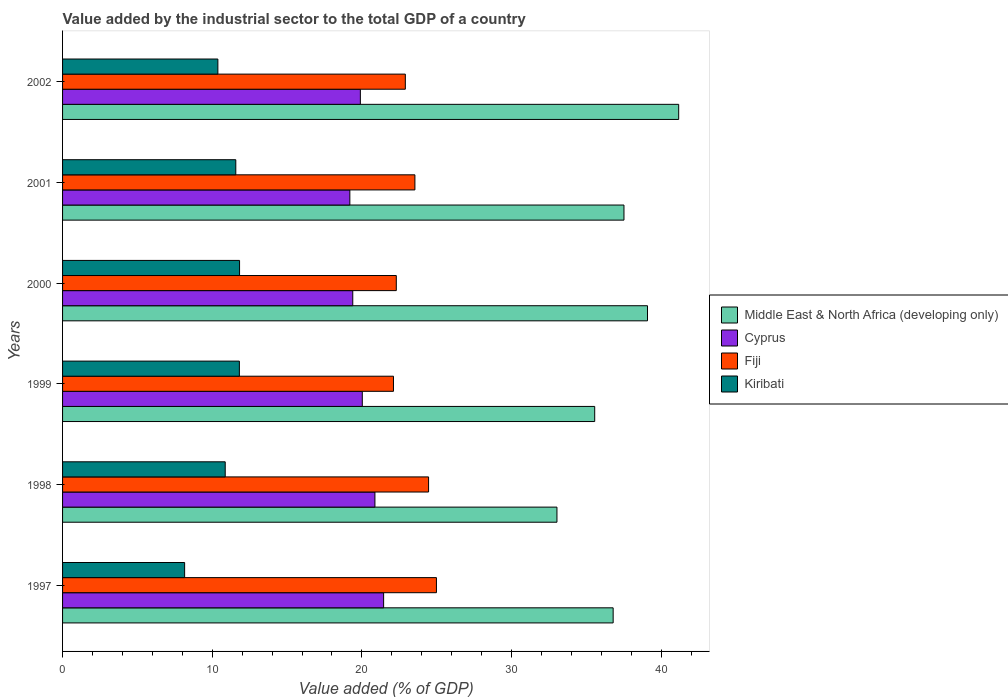How many groups of bars are there?
Give a very brief answer. 6. Are the number of bars on each tick of the Y-axis equal?
Keep it short and to the point. Yes. How many bars are there on the 2nd tick from the top?
Keep it short and to the point. 4. What is the value added by the industrial sector to the total GDP in Kiribati in 1999?
Provide a succinct answer. 11.81. Across all years, what is the maximum value added by the industrial sector to the total GDP in Middle East & North Africa (developing only)?
Keep it short and to the point. 41.16. Across all years, what is the minimum value added by the industrial sector to the total GDP in Kiribati?
Provide a short and direct response. 8.16. In which year was the value added by the industrial sector to the total GDP in Kiribati maximum?
Keep it short and to the point. 2000. What is the total value added by the industrial sector to the total GDP in Cyprus in the graph?
Keep it short and to the point. 120.82. What is the difference between the value added by the industrial sector to the total GDP in Cyprus in 1997 and that in 2001?
Give a very brief answer. 2.26. What is the difference between the value added by the industrial sector to the total GDP in Cyprus in 1998 and the value added by the industrial sector to the total GDP in Fiji in 2001?
Your answer should be very brief. -2.67. What is the average value added by the industrial sector to the total GDP in Cyprus per year?
Offer a very short reply. 20.14. In the year 1997, what is the difference between the value added by the industrial sector to the total GDP in Middle East & North Africa (developing only) and value added by the industrial sector to the total GDP in Fiji?
Provide a short and direct response. 11.81. What is the ratio of the value added by the industrial sector to the total GDP in Kiribati in 1997 to that in 2001?
Provide a short and direct response. 0.7. Is the difference between the value added by the industrial sector to the total GDP in Middle East & North Africa (developing only) in 2001 and 2002 greater than the difference between the value added by the industrial sector to the total GDP in Fiji in 2001 and 2002?
Your answer should be compact. No. What is the difference between the highest and the second highest value added by the industrial sector to the total GDP in Cyprus?
Your answer should be very brief. 0.58. What is the difference between the highest and the lowest value added by the industrial sector to the total GDP in Middle East & North Africa (developing only)?
Provide a succinct answer. 8.13. Is the sum of the value added by the industrial sector to the total GDP in Fiji in 1999 and 2002 greater than the maximum value added by the industrial sector to the total GDP in Middle East & North Africa (developing only) across all years?
Make the answer very short. Yes. What does the 4th bar from the top in 1998 represents?
Keep it short and to the point. Middle East & North Africa (developing only). What does the 1st bar from the bottom in 2000 represents?
Your answer should be very brief. Middle East & North Africa (developing only). How many bars are there?
Offer a terse response. 24. Are all the bars in the graph horizontal?
Make the answer very short. Yes. How many years are there in the graph?
Give a very brief answer. 6. Are the values on the major ticks of X-axis written in scientific E-notation?
Keep it short and to the point. No. Does the graph contain any zero values?
Your answer should be compact. No. What is the title of the graph?
Offer a terse response. Value added by the industrial sector to the total GDP of a country. What is the label or title of the X-axis?
Keep it short and to the point. Value added (% of GDP). What is the label or title of the Y-axis?
Your answer should be compact. Years. What is the Value added (% of GDP) of Middle East & North Africa (developing only) in 1997?
Keep it short and to the point. 36.79. What is the Value added (% of GDP) of Cyprus in 1997?
Offer a very short reply. 21.45. What is the Value added (% of GDP) in Fiji in 1997?
Offer a very short reply. 24.98. What is the Value added (% of GDP) of Kiribati in 1997?
Keep it short and to the point. 8.16. What is the Value added (% of GDP) in Middle East & North Africa (developing only) in 1998?
Offer a terse response. 33.03. What is the Value added (% of GDP) in Cyprus in 1998?
Keep it short and to the point. 20.87. What is the Value added (% of GDP) in Fiji in 1998?
Make the answer very short. 24.45. What is the Value added (% of GDP) of Kiribati in 1998?
Your answer should be compact. 10.87. What is the Value added (% of GDP) of Middle East & North Africa (developing only) in 1999?
Ensure brevity in your answer.  35.55. What is the Value added (% of GDP) of Cyprus in 1999?
Keep it short and to the point. 20.02. What is the Value added (% of GDP) in Fiji in 1999?
Provide a succinct answer. 22.11. What is the Value added (% of GDP) in Kiribati in 1999?
Provide a short and direct response. 11.81. What is the Value added (% of GDP) of Middle East & North Africa (developing only) in 2000?
Ensure brevity in your answer.  39.08. What is the Value added (% of GDP) in Cyprus in 2000?
Offer a terse response. 19.39. What is the Value added (% of GDP) of Fiji in 2000?
Make the answer very short. 22.3. What is the Value added (% of GDP) in Kiribati in 2000?
Keep it short and to the point. 11.82. What is the Value added (% of GDP) in Middle East & North Africa (developing only) in 2001?
Provide a succinct answer. 37.51. What is the Value added (% of GDP) in Cyprus in 2001?
Ensure brevity in your answer.  19.19. What is the Value added (% of GDP) in Fiji in 2001?
Offer a terse response. 23.54. What is the Value added (% of GDP) of Kiribati in 2001?
Ensure brevity in your answer.  11.57. What is the Value added (% of GDP) in Middle East & North Africa (developing only) in 2002?
Make the answer very short. 41.16. What is the Value added (% of GDP) in Cyprus in 2002?
Offer a very short reply. 19.9. What is the Value added (% of GDP) of Fiji in 2002?
Make the answer very short. 22.9. What is the Value added (% of GDP) in Kiribati in 2002?
Your response must be concise. 10.38. Across all years, what is the maximum Value added (% of GDP) of Middle East & North Africa (developing only)?
Give a very brief answer. 41.16. Across all years, what is the maximum Value added (% of GDP) in Cyprus?
Give a very brief answer. 21.45. Across all years, what is the maximum Value added (% of GDP) in Fiji?
Offer a terse response. 24.98. Across all years, what is the maximum Value added (% of GDP) in Kiribati?
Give a very brief answer. 11.82. Across all years, what is the minimum Value added (% of GDP) in Middle East & North Africa (developing only)?
Make the answer very short. 33.03. Across all years, what is the minimum Value added (% of GDP) of Cyprus?
Keep it short and to the point. 19.19. Across all years, what is the minimum Value added (% of GDP) of Fiji?
Your answer should be very brief. 22.11. Across all years, what is the minimum Value added (% of GDP) in Kiribati?
Your response must be concise. 8.16. What is the total Value added (% of GDP) in Middle East & North Africa (developing only) in the graph?
Keep it short and to the point. 223.12. What is the total Value added (% of GDP) of Cyprus in the graph?
Provide a short and direct response. 120.82. What is the total Value added (% of GDP) in Fiji in the graph?
Offer a very short reply. 140.28. What is the total Value added (% of GDP) in Kiribati in the graph?
Provide a succinct answer. 64.61. What is the difference between the Value added (% of GDP) in Middle East & North Africa (developing only) in 1997 and that in 1998?
Your answer should be very brief. 3.75. What is the difference between the Value added (% of GDP) in Cyprus in 1997 and that in 1998?
Provide a succinct answer. 0.58. What is the difference between the Value added (% of GDP) in Fiji in 1997 and that in 1998?
Your answer should be compact. 0.52. What is the difference between the Value added (% of GDP) of Kiribati in 1997 and that in 1998?
Ensure brevity in your answer.  -2.71. What is the difference between the Value added (% of GDP) of Middle East & North Africa (developing only) in 1997 and that in 1999?
Your answer should be very brief. 1.23. What is the difference between the Value added (% of GDP) of Cyprus in 1997 and that in 1999?
Your response must be concise. 1.43. What is the difference between the Value added (% of GDP) in Fiji in 1997 and that in 1999?
Offer a terse response. 2.87. What is the difference between the Value added (% of GDP) of Kiribati in 1997 and that in 1999?
Offer a terse response. -3.66. What is the difference between the Value added (% of GDP) of Middle East & North Africa (developing only) in 1997 and that in 2000?
Your answer should be compact. -2.29. What is the difference between the Value added (% of GDP) of Cyprus in 1997 and that in 2000?
Provide a succinct answer. 2.06. What is the difference between the Value added (% of GDP) in Fiji in 1997 and that in 2000?
Provide a short and direct response. 2.68. What is the difference between the Value added (% of GDP) of Kiribati in 1997 and that in 2000?
Your response must be concise. -3.67. What is the difference between the Value added (% of GDP) in Middle East & North Africa (developing only) in 1997 and that in 2001?
Provide a succinct answer. -0.72. What is the difference between the Value added (% of GDP) in Cyprus in 1997 and that in 2001?
Your answer should be very brief. 2.26. What is the difference between the Value added (% of GDP) in Fiji in 1997 and that in 2001?
Provide a short and direct response. 1.44. What is the difference between the Value added (% of GDP) in Kiribati in 1997 and that in 2001?
Keep it short and to the point. -3.42. What is the difference between the Value added (% of GDP) in Middle East & North Africa (developing only) in 1997 and that in 2002?
Provide a succinct answer. -4.38. What is the difference between the Value added (% of GDP) of Cyprus in 1997 and that in 2002?
Your answer should be very brief. 1.55. What is the difference between the Value added (% of GDP) in Fiji in 1997 and that in 2002?
Provide a short and direct response. 2.08. What is the difference between the Value added (% of GDP) in Kiribati in 1997 and that in 2002?
Offer a very short reply. -2.22. What is the difference between the Value added (% of GDP) of Middle East & North Africa (developing only) in 1998 and that in 1999?
Provide a short and direct response. -2.52. What is the difference between the Value added (% of GDP) in Cyprus in 1998 and that in 1999?
Offer a terse response. 0.84. What is the difference between the Value added (% of GDP) of Fiji in 1998 and that in 1999?
Offer a terse response. 2.35. What is the difference between the Value added (% of GDP) of Kiribati in 1998 and that in 1999?
Give a very brief answer. -0.95. What is the difference between the Value added (% of GDP) of Middle East & North Africa (developing only) in 1998 and that in 2000?
Provide a succinct answer. -6.05. What is the difference between the Value added (% of GDP) in Cyprus in 1998 and that in 2000?
Ensure brevity in your answer.  1.48. What is the difference between the Value added (% of GDP) in Fiji in 1998 and that in 2000?
Your answer should be very brief. 2.16. What is the difference between the Value added (% of GDP) in Kiribati in 1998 and that in 2000?
Ensure brevity in your answer.  -0.96. What is the difference between the Value added (% of GDP) in Middle East & North Africa (developing only) in 1998 and that in 2001?
Provide a succinct answer. -4.48. What is the difference between the Value added (% of GDP) in Cyprus in 1998 and that in 2001?
Your answer should be very brief. 1.68. What is the difference between the Value added (% of GDP) in Fiji in 1998 and that in 2001?
Give a very brief answer. 0.91. What is the difference between the Value added (% of GDP) in Kiribati in 1998 and that in 2001?
Provide a succinct answer. -0.71. What is the difference between the Value added (% of GDP) of Middle East & North Africa (developing only) in 1998 and that in 2002?
Provide a short and direct response. -8.13. What is the difference between the Value added (% of GDP) in Cyprus in 1998 and that in 2002?
Provide a succinct answer. 0.97. What is the difference between the Value added (% of GDP) of Fiji in 1998 and that in 2002?
Give a very brief answer. 1.55. What is the difference between the Value added (% of GDP) in Kiribati in 1998 and that in 2002?
Keep it short and to the point. 0.49. What is the difference between the Value added (% of GDP) in Middle East & North Africa (developing only) in 1999 and that in 2000?
Make the answer very short. -3.53. What is the difference between the Value added (% of GDP) in Cyprus in 1999 and that in 2000?
Provide a succinct answer. 0.64. What is the difference between the Value added (% of GDP) of Fiji in 1999 and that in 2000?
Make the answer very short. -0.19. What is the difference between the Value added (% of GDP) of Kiribati in 1999 and that in 2000?
Give a very brief answer. -0.01. What is the difference between the Value added (% of GDP) of Middle East & North Africa (developing only) in 1999 and that in 2001?
Make the answer very short. -1.96. What is the difference between the Value added (% of GDP) of Cyprus in 1999 and that in 2001?
Provide a short and direct response. 0.83. What is the difference between the Value added (% of GDP) in Fiji in 1999 and that in 2001?
Ensure brevity in your answer.  -1.43. What is the difference between the Value added (% of GDP) of Kiribati in 1999 and that in 2001?
Your answer should be very brief. 0.24. What is the difference between the Value added (% of GDP) of Middle East & North Africa (developing only) in 1999 and that in 2002?
Give a very brief answer. -5.61. What is the difference between the Value added (% of GDP) in Cyprus in 1999 and that in 2002?
Offer a terse response. 0.13. What is the difference between the Value added (% of GDP) in Fiji in 1999 and that in 2002?
Provide a short and direct response. -0.79. What is the difference between the Value added (% of GDP) in Kiribati in 1999 and that in 2002?
Make the answer very short. 1.44. What is the difference between the Value added (% of GDP) of Middle East & North Africa (developing only) in 2000 and that in 2001?
Provide a short and direct response. 1.57. What is the difference between the Value added (% of GDP) of Cyprus in 2000 and that in 2001?
Your answer should be very brief. 0.2. What is the difference between the Value added (% of GDP) of Fiji in 2000 and that in 2001?
Keep it short and to the point. -1.24. What is the difference between the Value added (% of GDP) of Kiribati in 2000 and that in 2001?
Offer a very short reply. 0.25. What is the difference between the Value added (% of GDP) of Middle East & North Africa (developing only) in 2000 and that in 2002?
Give a very brief answer. -2.08. What is the difference between the Value added (% of GDP) in Cyprus in 2000 and that in 2002?
Provide a short and direct response. -0.51. What is the difference between the Value added (% of GDP) in Fiji in 2000 and that in 2002?
Provide a short and direct response. -0.6. What is the difference between the Value added (% of GDP) of Kiribati in 2000 and that in 2002?
Your response must be concise. 1.45. What is the difference between the Value added (% of GDP) of Middle East & North Africa (developing only) in 2001 and that in 2002?
Give a very brief answer. -3.66. What is the difference between the Value added (% of GDP) in Cyprus in 2001 and that in 2002?
Offer a terse response. -0.7. What is the difference between the Value added (% of GDP) of Fiji in 2001 and that in 2002?
Give a very brief answer. 0.64. What is the difference between the Value added (% of GDP) of Kiribati in 2001 and that in 2002?
Keep it short and to the point. 1.2. What is the difference between the Value added (% of GDP) of Middle East & North Africa (developing only) in 1997 and the Value added (% of GDP) of Cyprus in 1998?
Provide a succinct answer. 15.92. What is the difference between the Value added (% of GDP) in Middle East & North Africa (developing only) in 1997 and the Value added (% of GDP) in Fiji in 1998?
Keep it short and to the point. 12.33. What is the difference between the Value added (% of GDP) of Middle East & North Africa (developing only) in 1997 and the Value added (% of GDP) of Kiribati in 1998?
Offer a terse response. 25.92. What is the difference between the Value added (% of GDP) of Cyprus in 1997 and the Value added (% of GDP) of Fiji in 1998?
Offer a terse response. -3. What is the difference between the Value added (% of GDP) in Cyprus in 1997 and the Value added (% of GDP) in Kiribati in 1998?
Your response must be concise. 10.58. What is the difference between the Value added (% of GDP) in Fiji in 1997 and the Value added (% of GDP) in Kiribati in 1998?
Offer a terse response. 14.11. What is the difference between the Value added (% of GDP) of Middle East & North Africa (developing only) in 1997 and the Value added (% of GDP) of Cyprus in 1999?
Provide a succinct answer. 16.76. What is the difference between the Value added (% of GDP) in Middle East & North Africa (developing only) in 1997 and the Value added (% of GDP) in Fiji in 1999?
Make the answer very short. 14.68. What is the difference between the Value added (% of GDP) of Middle East & North Africa (developing only) in 1997 and the Value added (% of GDP) of Kiribati in 1999?
Your answer should be compact. 24.97. What is the difference between the Value added (% of GDP) in Cyprus in 1997 and the Value added (% of GDP) in Fiji in 1999?
Provide a succinct answer. -0.66. What is the difference between the Value added (% of GDP) in Cyprus in 1997 and the Value added (% of GDP) in Kiribati in 1999?
Provide a short and direct response. 9.64. What is the difference between the Value added (% of GDP) of Fiji in 1997 and the Value added (% of GDP) of Kiribati in 1999?
Provide a short and direct response. 13.17. What is the difference between the Value added (% of GDP) of Middle East & North Africa (developing only) in 1997 and the Value added (% of GDP) of Cyprus in 2000?
Your answer should be compact. 17.4. What is the difference between the Value added (% of GDP) in Middle East & North Africa (developing only) in 1997 and the Value added (% of GDP) in Fiji in 2000?
Your answer should be compact. 14.49. What is the difference between the Value added (% of GDP) in Middle East & North Africa (developing only) in 1997 and the Value added (% of GDP) in Kiribati in 2000?
Make the answer very short. 24.96. What is the difference between the Value added (% of GDP) in Cyprus in 1997 and the Value added (% of GDP) in Fiji in 2000?
Keep it short and to the point. -0.85. What is the difference between the Value added (% of GDP) of Cyprus in 1997 and the Value added (% of GDP) of Kiribati in 2000?
Make the answer very short. 9.63. What is the difference between the Value added (% of GDP) in Fiji in 1997 and the Value added (% of GDP) in Kiribati in 2000?
Make the answer very short. 13.15. What is the difference between the Value added (% of GDP) of Middle East & North Africa (developing only) in 1997 and the Value added (% of GDP) of Cyprus in 2001?
Keep it short and to the point. 17.59. What is the difference between the Value added (% of GDP) in Middle East & North Africa (developing only) in 1997 and the Value added (% of GDP) in Fiji in 2001?
Provide a succinct answer. 13.24. What is the difference between the Value added (% of GDP) in Middle East & North Africa (developing only) in 1997 and the Value added (% of GDP) in Kiribati in 2001?
Your answer should be very brief. 25.21. What is the difference between the Value added (% of GDP) in Cyprus in 1997 and the Value added (% of GDP) in Fiji in 2001?
Ensure brevity in your answer.  -2.09. What is the difference between the Value added (% of GDP) in Cyprus in 1997 and the Value added (% of GDP) in Kiribati in 2001?
Keep it short and to the point. 9.88. What is the difference between the Value added (% of GDP) in Fiji in 1997 and the Value added (% of GDP) in Kiribati in 2001?
Your answer should be very brief. 13.4. What is the difference between the Value added (% of GDP) in Middle East & North Africa (developing only) in 1997 and the Value added (% of GDP) in Cyprus in 2002?
Provide a short and direct response. 16.89. What is the difference between the Value added (% of GDP) of Middle East & North Africa (developing only) in 1997 and the Value added (% of GDP) of Fiji in 2002?
Keep it short and to the point. 13.88. What is the difference between the Value added (% of GDP) in Middle East & North Africa (developing only) in 1997 and the Value added (% of GDP) in Kiribati in 2002?
Your answer should be very brief. 26.41. What is the difference between the Value added (% of GDP) in Cyprus in 1997 and the Value added (% of GDP) in Fiji in 2002?
Offer a very short reply. -1.45. What is the difference between the Value added (% of GDP) in Cyprus in 1997 and the Value added (% of GDP) in Kiribati in 2002?
Provide a succinct answer. 11.07. What is the difference between the Value added (% of GDP) in Fiji in 1997 and the Value added (% of GDP) in Kiribati in 2002?
Provide a short and direct response. 14.6. What is the difference between the Value added (% of GDP) of Middle East & North Africa (developing only) in 1998 and the Value added (% of GDP) of Cyprus in 1999?
Your answer should be compact. 13.01. What is the difference between the Value added (% of GDP) in Middle East & North Africa (developing only) in 1998 and the Value added (% of GDP) in Fiji in 1999?
Keep it short and to the point. 10.92. What is the difference between the Value added (% of GDP) in Middle East & North Africa (developing only) in 1998 and the Value added (% of GDP) in Kiribati in 1999?
Provide a short and direct response. 21.22. What is the difference between the Value added (% of GDP) in Cyprus in 1998 and the Value added (% of GDP) in Fiji in 1999?
Give a very brief answer. -1.24. What is the difference between the Value added (% of GDP) in Cyprus in 1998 and the Value added (% of GDP) in Kiribati in 1999?
Make the answer very short. 9.06. What is the difference between the Value added (% of GDP) in Fiji in 1998 and the Value added (% of GDP) in Kiribati in 1999?
Offer a very short reply. 12.64. What is the difference between the Value added (% of GDP) in Middle East & North Africa (developing only) in 1998 and the Value added (% of GDP) in Cyprus in 2000?
Make the answer very short. 13.64. What is the difference between the Value added (% of GDP) of Middle East & North Africa (developing only) in 1998 and the Value added (% of GDP) of Fiji in 2000?
Give a very brief answer. 10.73. What is the difference between the Value added (% of GDP) in Middle East & North Africa (developing only) in 1998 and the Value added (% of GDP) in Kiribati in 2000?
Keep it short and to the point. 21.21. What is the difference between the Value added (% of GDP) of Cyprus in 1998 and the Value added (% of GDP) of Fiji in 2000?
Give a very brief answer. -1.43. What is the difference between the Value added (% of GDP) of Cyprus in 1998 and the Value added (% of GDP) of Kiribati in 2000?
Your answer should be compact. 9.04. What is the difference between the Value added (% of GDP) of Fiji in 1998 and the Value added (% of GDP) of Kiribati in 2000?
Your response must be concise. 12.63. What is the difference between the Value added (% of GDP) of Middle East & North Africa (developing only) in 1998 and the Value added (% of GDP) of Cyprus in 2001?
Ensure brevity in your answer.  13.84. What is the difference between the Value added (% of GDP) of Middle East & North Africa (developing only) in 1998 and the Value added (% of GDP) of Fiji in 2001?
Offer a terse response. 9.49. What is the difference between the Value added (% of GDP) of Middle East & North Africa (developing only) in 1998 and the Value added (% of GDP) of Kiribati in 2001?
Provide a short and direct response. 21.46. What is the difference between the Value added (% of GDP) in Cyprus in 1998 and the Value added (% of GDP) in Fiji in 2001?
Provide a succinct answer. -2.67. What is the difference between the Value added (% of GDP) of Cyprus in 1998 and the Value added (% of GDP) of Kiribati in 2001?
Make the answer very short. 9.3. What is the difference between the Value added (% of GDP) of Fiji in 1998 and the Value added (% of GDP) of Kiribati in 2001?
Provide a succinct answer. 12.88. What is the difference between the Value added (% of GDP) in Middle East & North Africa (developing only) in 1998 and the Value added (% of GDP) in Cyprus in 2002?
Your answer should be very brief. 13.14. What is the difference between the Value added (% of GDP) of Middle East & North Africa (developing only) in 1998 and the Value added (% of GDP) of Fiji in 2002?
Offer a terse response. 10.13. What is the difference between the Value added (% of GDP) in Middle East & North Africa (developing only) in 1998 and the Value added (% of GDP) in Kiribati in 2002?
Offer a terse response. 22.65. What is the difference between the Value added (% of GDP) of Cyprus in 1998 and the Value added (% of GDP) of Fiji in 2002?
Ensure brevity in your answer.  -2.03. What is the difference between the Value added (% of GDP) in Cyprus in 1998 and the Value added (% of GDP) in Kiribati in 2002?
Make the answer very short. 10.49. What is the difference between the Value added (% of GDP) in Fiji in 1998 and the Value added (% of GDP) in Kiribati in 2002?
Offer a very short reply. 14.08. What is the difference between the Value added (% of GDP) of Middle East & North Africa (developing only) in 1999 and the Value added (% of GDP) of Cyprus in 2000?
Offer a very short reply. 16.16. What is the difference between the Value added (% of GDP) in Middle East & North Africa (developing only) in 1999 and the Value added (% of GDP) in Fiji in 2000?
Ensure brevity in your answer.  13.26. What is the difference between the Value added (% of GDP) of Middle East & North Africa (developing only) in 1999 and the Value added (% of GDP) of Kiribati in 2000?
Provide a short and direct response. 23.73. What is the difference between the Value added (% of GDP) in Cyprus in 1999 and the Value added (% of GDP) in Fiji in 2000?
Your response must be concise. -2.27. What is the difference between the Value added (% of GDP) of Cyprus in 1999 and the Value added (% of GDP) of Kiribati in 2000?
Provide a short and direct response. 8.2. What is the difference between the Value added (% of GDP) in Fiji in 1999 and the Value added (% of GDP) in Kiribati in 2000?
Provide a short and direct response. 10.28. What is the difference between the Value added (% of GDP) in Middle East & North Africa (developing only) in 1999 and the Value added (% of GDP) in Cyprus in 2001?
Provide a succinct answer. 16.36. What is the difference between the Value added (% of GDP) of Middle East & North Africa (developing only) in 1999 and the Value added (% of GDP) of Fiji in 2001?
Your response must be concise. 12.01. What is the difference between the Value added (% of GDP) in Middle East & North Africa (developing only) in 1999 and the Value added (% of GDP) in Kiribati in 2001?
Provide a succinct answer. 23.98. What is the difference between the Value added (% of GDP) of Cyprus in 1999 and the Value added (% of GDP) of Fiji in 2001?
Provide a short and direct response. -3.52. What is the difference between the Value added (% of GDP) in Cyprus in 1999 and the Value added (% of GDP) in Kiribati in 2001?
Make the answer very short. 8.45. What is the difference between the Value added (% of GDP) of Fiji in 1999 and the Value added (% of GDP) of Kiribati in 2001?
Your response must be concise. 10.53. What is the difference between the Value added (% of GDP) of Middle East & North Africa (developing only) in 1999 and the Value added (% of GDP) of Cyprus in 2002?
Make the answer very short. 15.66. What is the difference between the Value added (% of GDP) of Middle East & North Africa (developing only) in 1999 and the Value added (% of GDP) of Fiji in 2002?
Give a very brief answer. 12.65. What is the difference between the Value added (% of GDP) in Middle East & North Africa (developing only) in 1999 and the Value added (% of GDP) in Kiribati in 2002?
Your answer should be very brief. 25.18. What is the difference between the Value added (% of GDP) in Cyprus in 1999 and the Value added (% of GDP) in Fiji in 2002?
Keep it short and to the point. -2.88. What is the difference between the Value added (% of GDP) of Cyprus in 1999 and the Value added (% of GDP) of Kiribati in 2002?
Provide a short and direct response. 9.65. What is the difference between the Value added (% of GDP) in Fiji in 1999 and the Value added (% of GDP) in Kiribati in 2002?
Ensure brevity in your answer.  11.73. What is the difference between the Value added (% of GDP) in Middle East & North Africa (developing only) in 2000 and the Value added (% of GDP) in Cyprus in 2001?
Your answer should be very brief. 19.89. What is the difference between the Value added (% of GDP) of Middle East & North Africa (developing only) in 2000 and the Value added (% of GDP) of Fiji in 2001?
Offer a very short reply. 15.54. What is the difference between the Value added (% of GDP) in Middle East & North Africa (developing only) in 2000 and the Value added (% of GDP) in Kiribati in 2001?
Offer a very short reply. 27.51. What is the difference between the Value added (% of GDP) in Cyprus in 2000 and the Value added (% of GDP) in Fiji in 2001?
Your answer should be compact. -4.15. What is the difference between the Value added (% of GDP) in Cyprus in 2000 and the Value added (% of GDP) in Kiribati in 2001?
Your answer should be compact. 7.81. What is the difference between the Value added (% of GDP) of Fiji in 2000 and the Value added (% of GDP) of Kiribati in 2001?
Keep it short and to the point. 10.72. What is the difference between the Value added (% of GDP) of Middle East & North Africa (developing only) in 2000 and the Value added (% of GDP) of Cyprus in 2002?
Make the answer very short. 19.18. What is the difference between the Value added (% of GDP) of Middle East & North Africa (developing only) in 2000 and the Value added (% of GDP) of Fiji in 2002?
Ensure brevity in your answer.  16.18. What is the difference between the Value added (% of GDP) of Middle East & North Africa (developing only) in 2000 and the Value added (% of GDP) of Kiribati in 2002?
Offer a terse response. 28.7. What is the difference between the Value added (% of GDP) in Cyprus in 2000 and the Value added (% of GDP) in Fiji in 2002?
Provide a succinct answer. -3.51. What is the difference between the Value added (% of GDP) in Cyprus in 2000 and the Value added (% of GDP) in Kiribati in 2002?
Provide a succinct answer. 9.01. What is the difference between the Value added (% of GDP) of Fiji in 2000 and the Value added (% of GDP) of Kiribati in 2002?
Ensure brevity in your answer.  11.92. What is the difference between the Value added (% of GDP) of Middle East & North Africa (developing only) in 2001 and the Value added (% of GDP) of Cyprus in 2002?
Ensure brevity in your answer.  17.61. What is the difference between the Value added (% of GDP) of Middle East & North Africa (developing only) in 2001 and the Value added (% of GDP) of Fiji in 2002?
Keep it short and to the point. 14.61. What is the difference between the Value added (% of GDP) of Middle East & North Africa (developing only) in 2001 and the Value added (% of GDP) of Kiribati in 2002?
Provide a short and direct response. 27.13. What is the difference between the Value added (% of GDP) in Cyprus in 2001 and the Value added (% of GDP) in Fiji in 2002?
Provide a succinct answer. -3.71. What is the difference between the Value added (% of GDP) in Cyprus in 2001 and the Value added (% of GDP) in Kiribati in 2002?
Your answer should be very brief. 8.82. What is the difference between the Value added (% of GDP) of Fiji in 2001 and the Value added (% of GDP) of Kiribati in 2002?
Keep it short and to the point. 13.16. What is the average Value added (% of GDP) of Middle East & North Africa (developing only) per year?
Your response must be concise. 37.19. What is the average Value added (% of GDP) of Cyprus per year?
Offer a very short reply. 20.14. What is the average Value added (% of GDP) of Fiji per year?
Give a very brief answer. 23.38. What is the average Value added (% of GDP) of Kiribati per year?
Provide a succinct answer. 10.77. In the year 1997, what is the difference between the Value added (% of GDP) in Middle East & North Africa (developing only) and Value added (% of GDP) in Cyprus?
Make the answer very short. 15.33. In the year 1997, what is the difference between the Value added (% of GDP) in Middle East & North Africa (developing only) and Value added (% of GDP) in Fiji?
Provide a short and direct response. 11.81. In the year 1997, what is the difference between the Value added (% of GDP) of Middle East & North Africa (developing only) and Value added (% of GDP) of Kiribati?
Make the answer very short. 28.63. In the year 1997, what is the difference between the Value added (% of GDP) in Cyprus and Value added (% of GDP) in Fiji?
Offer a terse response. -3.53. In the year 1997, what is the difference between the Value added (% of GDP) of Cyprus and Value added (% of GDP) of Kiribati?
Provide a succinct answer. 13.3. In the year 1997, what is the difference between the Value added (% of GDP) of Fiji and Value added (% of GDP) of Kiribati?
Ensure brevity in your answer.  16.82. In the year 1998, what is the difference between the Value added (% of GDP) in Middle East & North Africa (developing only) and Value added (% of GDP) in Cyprus?
Make the answer very short. 12.16. In the year 1998, what is the difference between the Value added (% of GDP) of Middle East & North Africa (developing only) and Value added (% of GDP) of Fiji?
Ensure brevity in your answer.  8.58. In the year 1998, what is the difference between the Value added (% of GDP) of Middle East & North Africa (developing only) and Value added (% of GDP) of Kiribati?
Offer a very short reply. 22.16. In the year 1998, what is the difference between the Value added (% of GDP) of Cyprus and Value added (% of GDP) of Fiji?
Give a very brief answer. -3.58. In the year 1998, what is the difference between the Value added (% of GDP) of Cyprus and Value added (% of GDP) of Kiribati?
Keep it short and to the point. 10. In the year 1998, what is the difference between the Value added (% of GDP) of Fiji and Value added (% of GDP) of Kiribati?
Provide a succinct answer. 13.59. In the year 1999, what is the difference between the Value added (% of GDP) in Middle East & North Africa (developing only) and Value added (% of GDP) in Cyprus?
Ensure brevity in your answer.  15.53. In the year 1999, what is the difference between the Value added (% of GDP) of Middle East & North Africa (developing only) and Value added (% of GDP) of Fiji?
Provide a short and direct response. 13.44. In the year 1999, what is the difference between the Value added (% of GDP) in Middle East & North Africa (developing only) and Value added (% of GDP) in Kiribati?
Make the answer very short. 23.74. In the year 1999, what is the difference between the Value added (% of GDP) in Cyprus and Value added (% of GDP) in Fiji?
Provide a succinct answer. -2.08. In the year 1999, what is the difference between the Value added (% of GDP) in Cyprus and Value added (% of GDP) in Kiribati?
Keep it short and to the point. 8.21. In the year 1999, what is the difference between the Value added (% of GDP) of Fiji and Value added (% of GDP) of Kiribati?
Offer a very short reply. 10.3. In the year 2000, what is the difference between the Value added (% of GDP) in Middle East & North Africa (developing only) and Value added (% of GDP) in Cyprus?
Your answer should be compact. 19.69. In the year 2000, what is the difference between the Value added (% of GDP) of Middle East & North Africa (developing only) and Value added (% of GDP) of Fiji?
Give a very brief answer. 16.78. In the year 2000, what is the difference between the Value added (% of GDP) of Middle East & North Africa (developing only) and Value added (% of GDP) of Kiribati?
Ensure brevity in your answer.  27.25. In the year 2000, what is the difference between the Value added (% of GDP) of Cyprus and Value added (% of GDP) of Fiji?
Provide a short and direct response. -2.91. In the year 2000, what is the difference between the Value added (% of GDP) of Cyprus and Value added (% of GDP) of Kiribati?
Your answer should be very brief. 7.56. In the year 2000, what is the difference between the Value added (% of GDP) of Fiji and Value added (% of GDP) of Kiribati?
Provide a short and direct response. 10.47. In the year 2001, what is the difference between the Value added (% of GDP) of Middle East & North Africa (developing only) and Value added (% of GDP) of Cyprus?
Provide a succinct answer. 18.32. In the year 2001, what is the difference between the Value added (% of GDP) of Middle East & North Africa (developing only) and Value added (% of GDP) of Fiji?
Give a very brief answer. 13.97. In the year 2001, what is the difference between the Value added (% of GDP) of Middle East & North Africa (developing only) and Value added (% of GDP) of Kiribati?
Offer a very short reply. 25.93. In the year 2001, what is the difference between the Value added (% of GDP) in Cyprus and Value added (% of GDP) in Fiji?
Ensure brevity in your answer.  -4.35. In the year 2001, what is the difference between the Value added (% of GDP) in Cyprus and Value added (% of GDP) in Kiribati?
Offer a very short reply. 7.62. In the year 2001, what is the difference between the Value added (% of GDP) in Fiji and Value added (% of GDP) in Kiribati?
Offer a terse response. 11.97. In the year 2002, what is the difference between the Value added (% of GDP) of Middle East & North Africa (developing only) and Value added (% of GDP) of Cyprus?
Provide a short and direct response. 21.27. In the year 2002, what is the difference between the Value added (% of GDP) of Middle East & North Africa (developing only) and Value added (% of GDP) of Fiji?
Your response must be concise. 18.26. In the year 2002, what is the difference between the Value added (% of GDP) of Middle East & North Africa (developing only) and Value added (% of GDP) of Kiribati?
Keep it short and to the point. 30.79. In the year 2002, what is the difference between the Value added (% of GDP) of Cyprus and Value added (% of GDP) of Fiji?
Your answer should be compact. -3. In the year 2002, what is the difference between the Value added (% of GDP) in Cyprus and Value added (% of GDP) in Kiribati?
Your response must be concise. 9.52. In the year 2002, what is the difference between the Value added (% of GDP) of Fiji and Value added (% of GDP) of Kiribati?
Your answer should be very brief. 12.52. What is the ratio of the Value added (% of GDP) of Middle East & North Africa (developing only) in 1997 to that in 1998?
Offer a terse response. 1.11. What is the ratio of the Value added (% of GDP) in Cyprus in 1997 to that in 1998?
Keep it short and to the point. 1.03. What is the ratio of the Value added (% of GDP) of Fiji in 1997 to that in 1998?
Ensure brevity in your answer.  1.02. What is the ratio of the Value added (% of GDP) in Kiribati in 1997 to that in 1998?
Offer a terse response. 0.75. What is the ratio of the Value added (% of GDP) of Middle East & North Africa (developing only) in 1997 to that in 1999?
Ensure brevity in your answer.  1.03. What is the ratio of the Value added (% of GDP) of Cyprus in 1997 to that in 1999?
Your answer should be compact. 1.07. What is the ratio of the Value added (% of GDP) of Fiji in 1997 to that in 1999?
Provide a short and direct response. 1.13. What is the ratio of the Value added (% of GDP) of Kiribati in 1997 to that in 1999?
Provide a succinct answer. 0.69. What is the ratio of the Value added (% of GDP) of Middle East & North Africa (developing only) in 1997 to that in 2000?
Make the answer very short. 0.94. What is the ratio of the Value added (% of GDP) in Cyprus in 1997 to that in 2000?
Provide a short and direct response. 1.11. What is the ratio of the Value added (% of GDP) in Fiji in 1997 to that in 2000?
Give a very brief answer. 1.12. What is the ratio of the Value added (% of GDP) of Kiribati in 1997 to that in 2000?
Provide a short and direct response. 0.69. What is the ratio of the Value added (% of GDP) of Middle East & North Africa (developing only) in 1997 to that in 2001?
Your answer should be very brief. 0.98. What is the ratio of the Value added (% of GDP) of Cyprus in 1997 to that in 2001?
Your response must be concise. 1.12. What is the ratio of the Value added (% of GDP) of Fiji in 1997 to that in 2001?
Keep it short and to the point. 1.06. What is the ratio of the Value added (% of GDP) in Kiribati in 1997 to that in 2001?
Make the answer very short. 0.7. What is the ratio of the Value added (% of GDP) in Middle East & North Africa (developing only) in 1997 to that in 2002?
Offer a terse response. 0.89. What is the ratio of the Value added (% of GDP) in Cyprus in 1997 to that in 2002?
Give a very brief answer. 1.08. What is the ratio of the Value added (% of GDP) in Fiji in 1997 to that in 2002?
Your answer should be very brief. 1.09. What is the ratio of the Value added (% of GDP) of Kiribati in 1997 to that in 2002?
Your answer should be compact. 0.79. What is the ratio of the Value added (% of GDP) in Middle East & North Africa (developing only) in 1998 to that in 1999?
Give a very brief answer. 0.93. What is the ratio of the Value added (% of GDP) in Cyprus in 1998 to that in 1999?
Provide a short and direct response. 1.04. What is the ratio of the Value added (% of GDP) in Fiji in 1998 to that in 1999?
Offer a terse response. 1.11. What is the ratio of the Value added (% of GDP) of Middle East & North Africa (developing only) in 1998 to that in 2000?
Your response must be concise. 0.85. What is the ratio of the Value added (% of GDP) in Cyprus in 1998 to that in 2000?
Give a very brief answer. 1.08. What is the ratio of the Value added (% of GDP) of Fiji in 1998 to that in 2000?
Give a very brief answer. 1.1. What is the ratio of the Value added (% of GDP) of Kiribati in 1998 to that in 2000?
Keep it short and to the point. 0.92. What is the ratio of the Value added (% of GDP) in Middle East & North Africa (developing only) in 1998 to that in 2001?
Offer a very short reply. 0.88. What is the ratio of the Value added (% of GDP) of Cyprus in 1998 to that in 2001?
Your answer should be compact. 1.09. What is the ratio of the Value added (% of GDP) of Fiji in 1998 to that in 2001?
Make the answer very short. 1.04. What is the ratio of the Value added (% of GDP) of Kiribati in 1998 to that in 2001?
Offer a very short reply. 0.94. What is the ratio of the Value added (% of GDP) of Middle East & North Africa (developing only) in 1998 to that in 2002?
Keep it short and to the point. 0.8. What is the ratio of the Value added (% of GDP) of Cyprus in 1998 to that in 2002?
Provide a short and direct response. 1.05. What is the ratio of the Value added (% of GDP) of Fiji in 1998 to that in 2002?
Ensure brevity in your answer.  1.07. What is the ratio of the Value added (% of GDP) in Kiribati in 1998 to that in 2002?
Ensure brevity in your answer.  1.05. What is the ratio of the Value added (% of GDP) of Middle East & North Africa (developing only) in 1999 to that in 2000?
Keep it short and to the point. 0.91. What is the ratio of the Value added (% of GDP) in Cyprus in 1999 to that in 2000?
Offer a terse response. 1.03. What is the ratio of the Value added (% of GDP) in Kiribati in 1999 to that in 2000?
Keep it short and to the point. 1. What is the ratio of the Value added (% of GDP) in Middle East & North Africa (developing only) in 1999 to that in 2001?
Your answer should be very brief. 0.95. What is the ratio of the Value added (% of GDP) of Cyprus in 1999 to that in 2001?
Your answer should be compact. 1.04. What is the ratio of the Value added (% of GDP) in Fiji in 1999 to that in 2001?
Your answer should be compact. 0.94. What is the ratio of the Value added (% of GDP) of Kiribati in 1999 to that in 2001?
Keep it short and to the point. 1.02. What is the ratio of the Value added (% of GDP) of Middle East & North Africa (developing only) in 1999 to that in 2002?
Your answer should be compact. 0.86. What is the ratio of the Value added (% of GDP) in Fiji in 1999 to that in 2002?
Provide a succinct answer. 0.97. What is the ratio of the Value added (% of GDP) in Kiribati in 1999 to that in 2002?
Keep it short and to the point. 1.14. What is the ratio of the Value added (% of GDP) in Middle East & North Africa (developing only) in 2000 to that in 2001?
Your answer should be very brief. 1.04. What is the ratio of the Value added (% of GDP) in Cyprus in 2000 to that in 2001?
Your response must be concise. 1.01. What is the ratio of the Value added (% of GDP) in Fiji in 2000 to that in 2001?
Your response must be concise. 0.95. What is the ratio of the Value added (% of GDP) of Kiribati in 2000 to that in 2001?
Offer a very short reply. 1.02. What is the ratio of the Value added (% of GDP) in Middle East & North Africa (developing only) in 2000 to that in 2002?
Give a very brief answer. 0.95. What is the ratio of the Value added (% of GDP) in Cyprus in 2000 to that in 2002?
Your response must be concise. 0.97. What is the ratio of the Value added (% of GDP) in Fiji in 2000 to that in 2002?
Your answer should be very brief. 0.97. What is the ratio of the Value added (% of GDP) of Kiribati in 2000 to that in 2002?
Keep it short and to the point. 1.14. What is the ratio of the Value added (% of GDP) in Middle East & North Africa (developing only) in 2001 to that in 2002?
Ensure brevity in your answer.  0.91. What is the ratio of the Value added (% of GDP) of Cyprus in 2001 to that in 2002?
Your answer should be very brief. 0.96. What is the ratio of the Value added (% of GDP) in Fiji in 2001 to that in 2002?
Your response must be concise. 1.03. What is the ratio of the Value added (% of GDP) of Kiribati in 2001 to that in 2002?
Provide a succinct answer. 1.12. What is the difference between the highest and the second highest Value added (% of GDP) in Middle East & North Africa (developing only)?
Your answer should be compact. 2.08. What is the difference between the highest and the second highest Value added (% of GDP) in Cyprus?
Your response must be concise. 0.58. What is the difference between the highest and the second highest Value added (% of GDP) in Fiji?
Provide a succinct answer. 0.52. What is the difference between the highest and the second highest Value added (% of GDP) of Kiribati?
Provide a succinct answer. 0.01. What is the difference between the highest and the lowest Value added (% of GDP) of Middle East & North Africa (developing only)?
Offer a terse response. 8.13. What is the difference between the highest and the lowest Value added (% of GDP) in Cyprus?
Provide a succinct answer. 2.26. What is the difference between the highest and the lowest Value added (% of GDP) in Fiji?
Offer a very short reply. 2.87. What is the difference between the highest and the lowest Value added (% of GDP) of Kiribati?
Your answer should be compact. 3.67. 